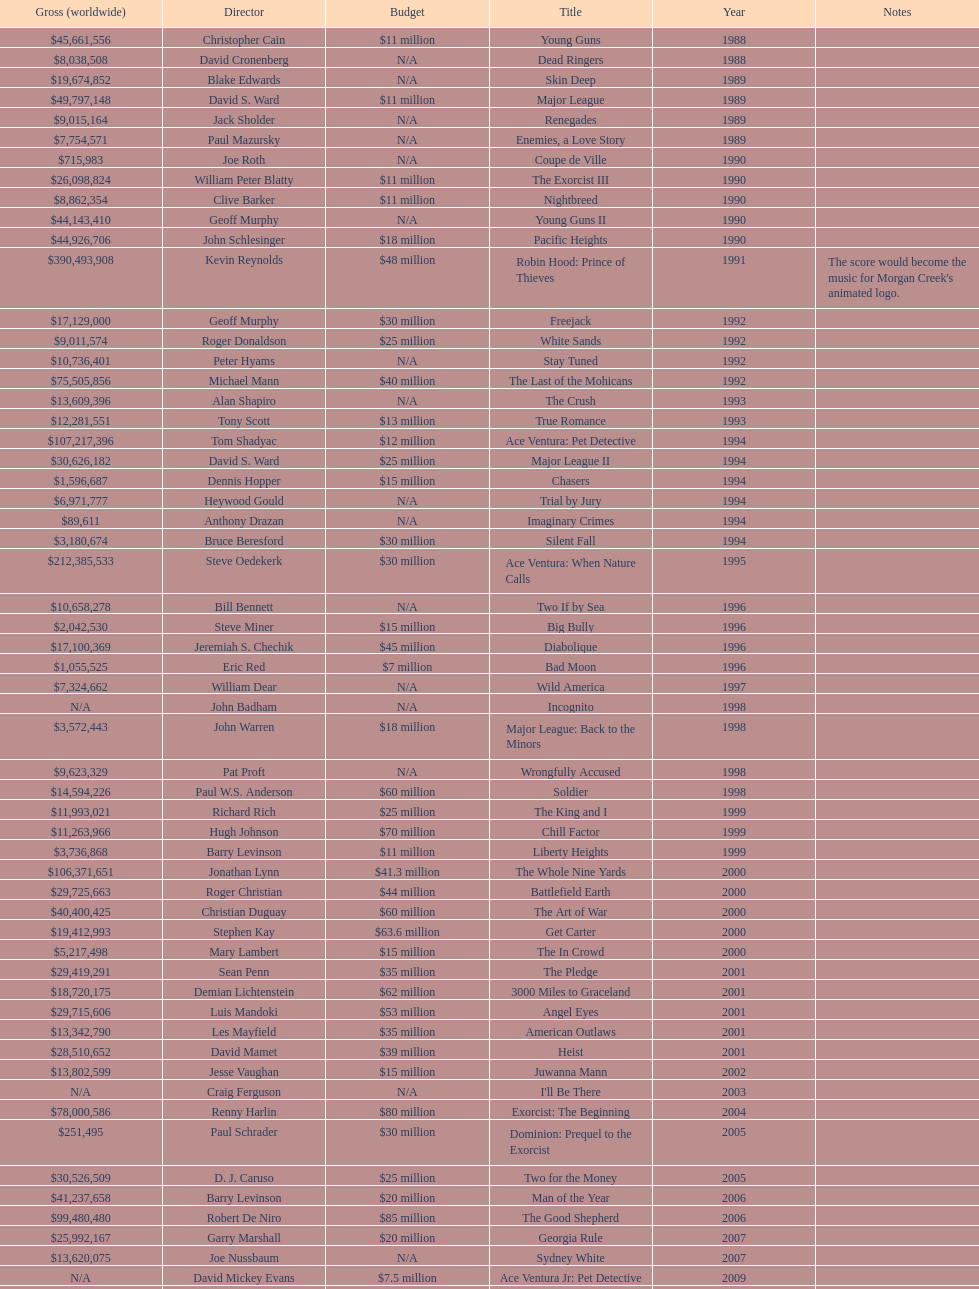What was the only movie with a 48 million dollar budget? Robin Hood: Prince of Thieves. 